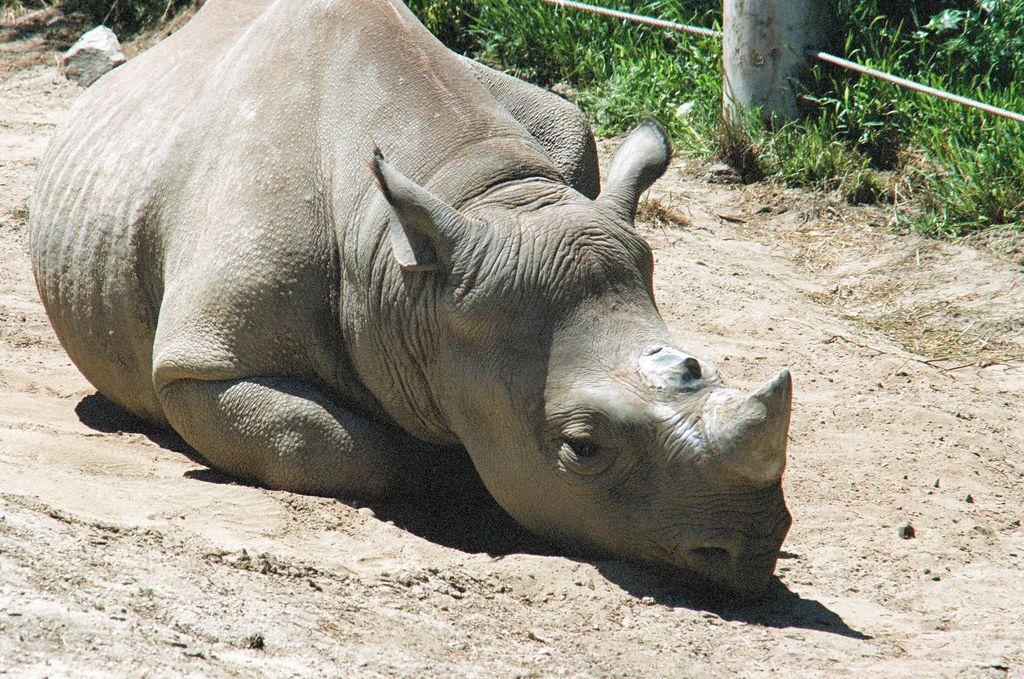Could you give a brief overview of what you see in this image? In this image we can see an animal on the ground. In the background we can see grass, stone, rope, and an object. 